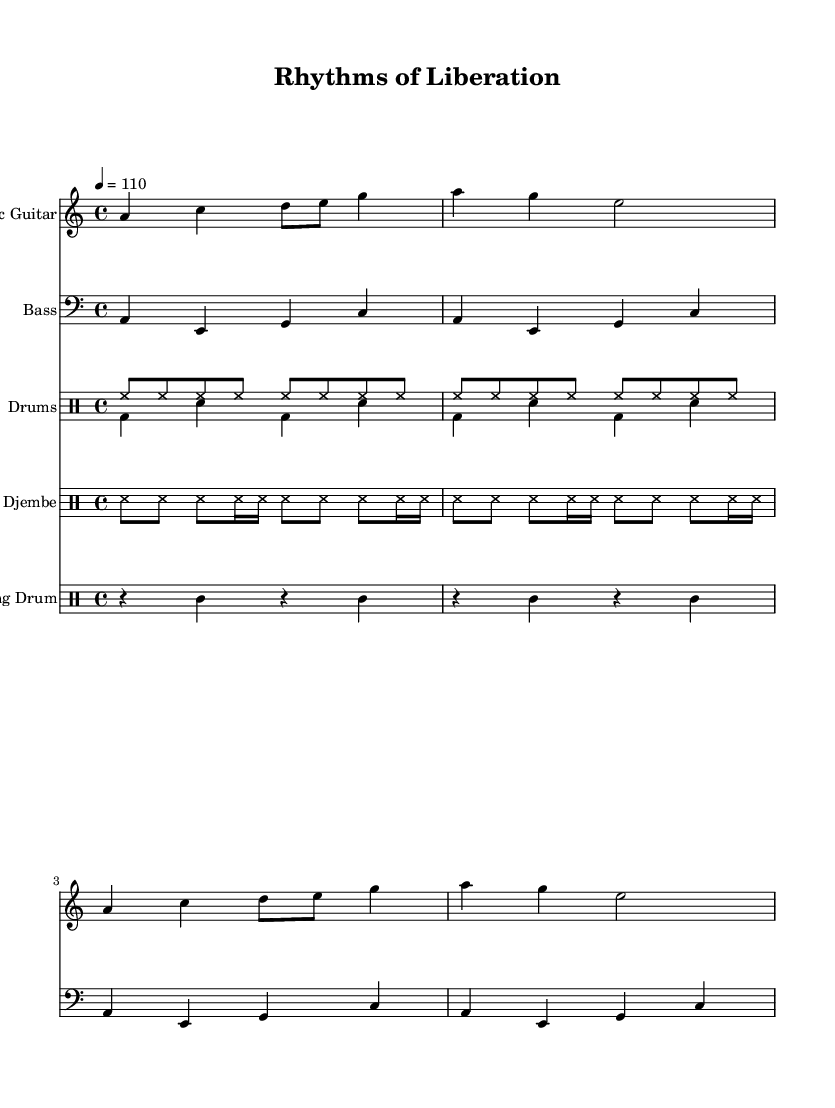What is the key signature of this music? The key signature is A minor, which contains no sharps or flats. It can be identified by looking at the key signature indication at the beginning of the staff.
Answer: A minor What is the time signature of this piece? The time signature is 4/4, indicated at the beginning of the score. It shows that there are four beats in each measure and the quarter note gets one beat.
Answer: 4/4 What is the tempo marking in this score? The tempo marking is a quarter note = 110, meaning the piece should be played at a speed of 110 beats per minute. This is usually seen at the beginning of the score as a tempo directive.
Answer: 110 How many measures are in the electric guitar part? The electric guitar part has 4 measures, which can be counted by looking at the number of vertical lines (bar lines) that separate the sections of music.
Answer: 4 What is the name of the traditional African instrument included in this piece? The traditional African instrument included is the djembe, as indicated in the instrumentation section of the score.
Answer: Djembe What type of rhythmic pattern does the talking drum use? The talking drum uses a rhythm that alternates between rests and sounds, indicated by the 'r' for rest and 'tt' for the hits within each measure. This pattern contributes to a call-and-response feel typical of traditional African music.
Answer: Alternating rests and hits Which instruments are playing a steady eighth-note rhythm? The instruments playing a steady eighth-note rhythm include the hi-hat in the drums and the djembe, as indicated by their respective notations in the score. Both maintain consistent eighth note patterns throughout their sections.
Answer: Hi-hat and djembe 